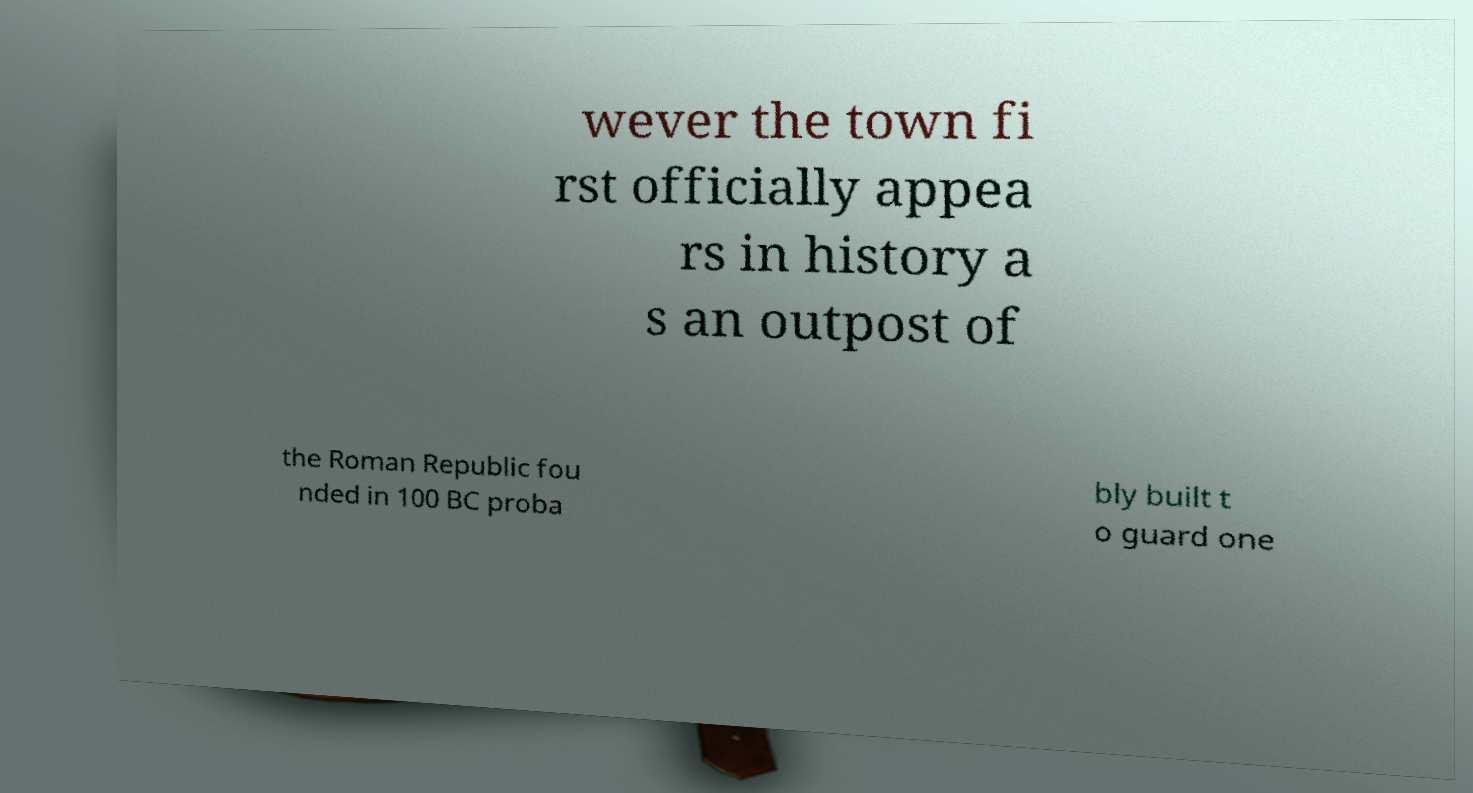What messages or text are displayed in this image? I need them in a readable, typed format. wever the town fi rst officially appea rs in history a s an outpost of the Roman Republic fou nded in 100 BC proba bly built t o guard one 